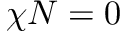Convert formula to latex. <formula><loc_0><loc_0><loc_500><loc_500>\chi N = 0</formula> 